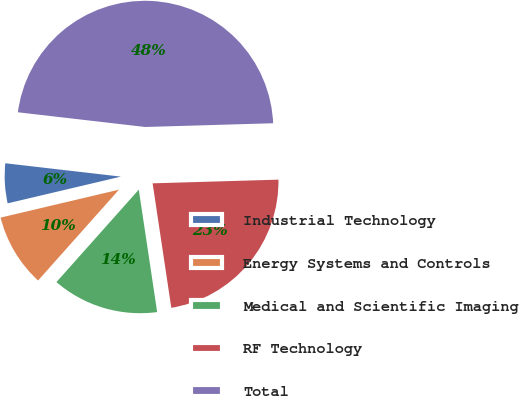<chart> <loc_0><loc_0><loc_500><loc_500><pie_chart><fcel>Industrial Technology<fcel>Energy Systems and Controls<fcel>Medical and Scientific Imaging<fcel>RF Technology<fcel>Total<nl><fcel>5.52%<fcel>9.73%<fcel>13.95%<fcel>23.09%<fcel>47.7%<nl></chart> 